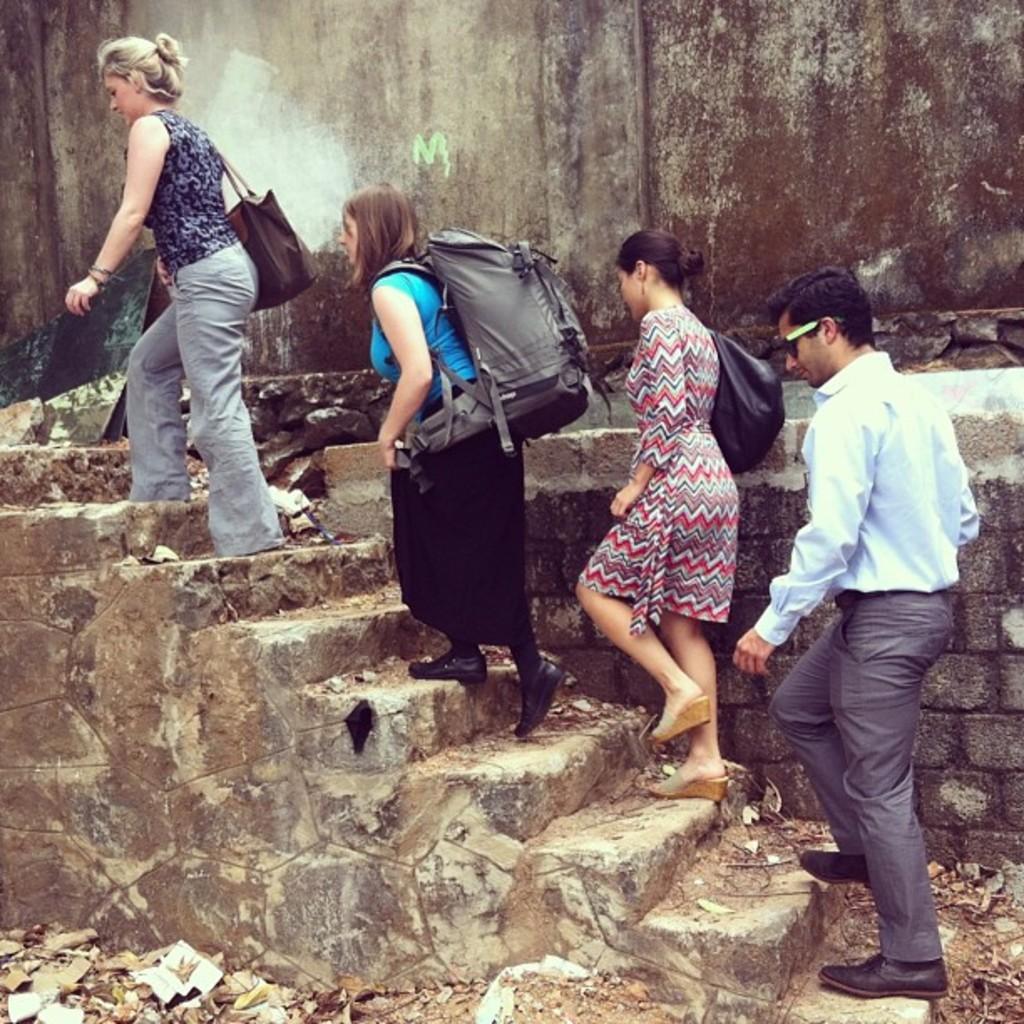Could you give a brief overview of what you see in this image? In this picture, we see three women and a man in white shirt are climbing up the staircase. Women are wearing handbags and backpack. At the bottom of the picture, we see dried leaves and twigs. In the background, we see a wall. 